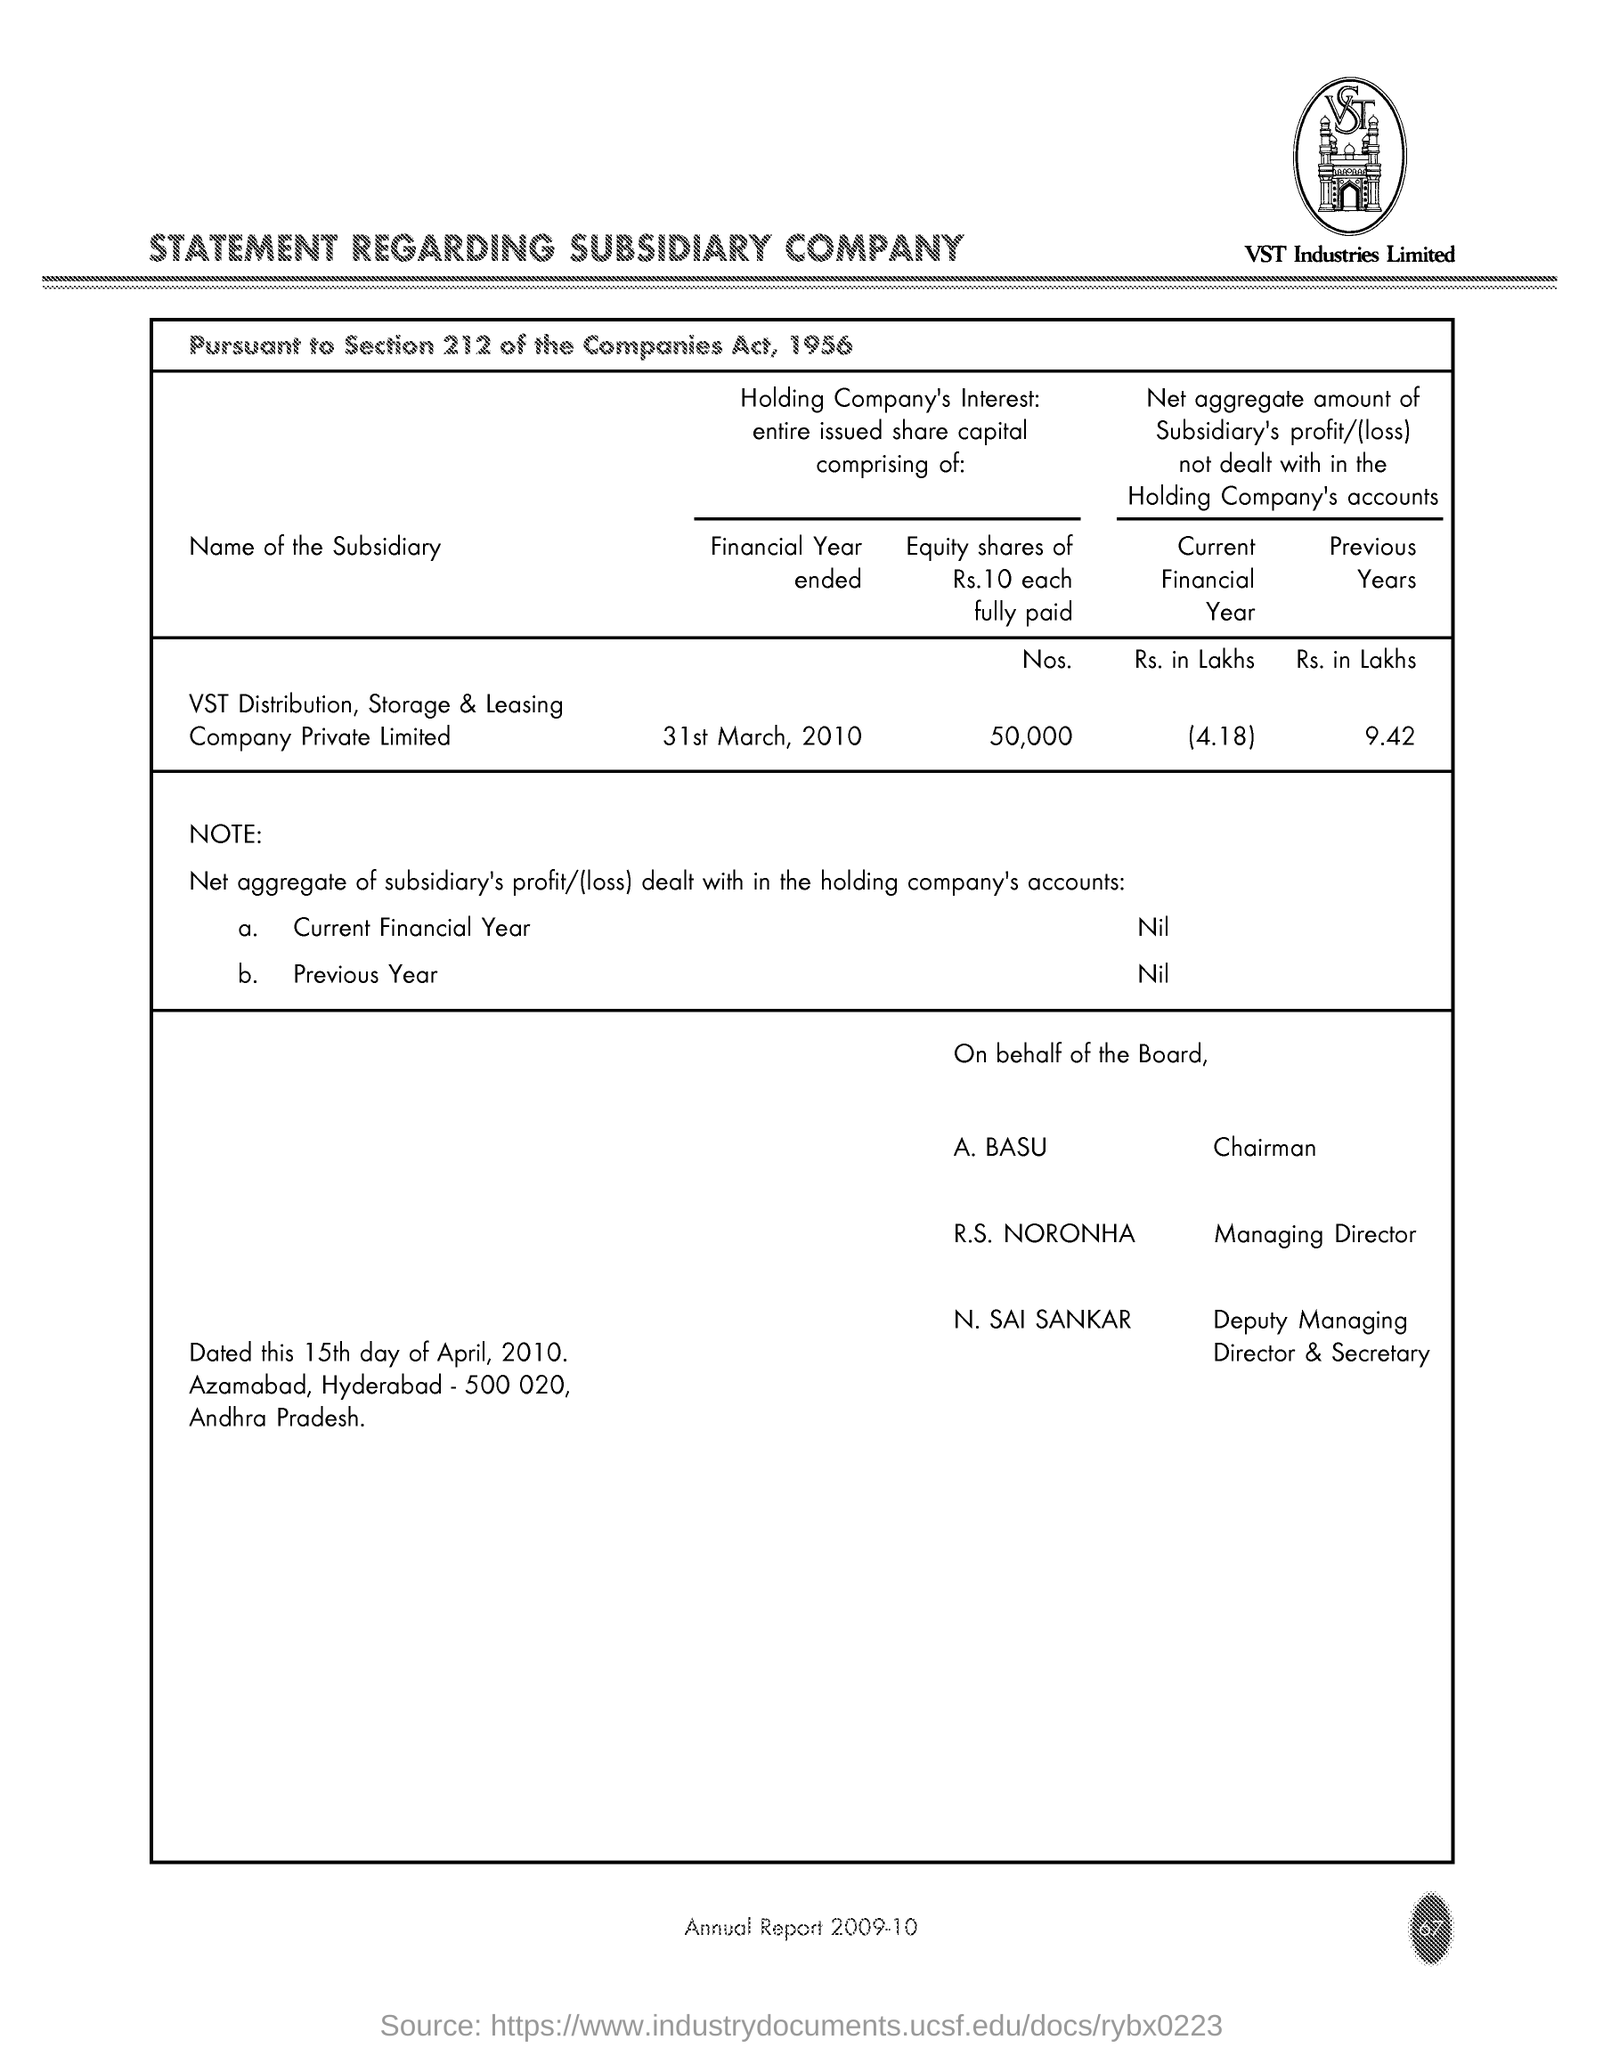Mention a couple of crucial points in this snapshot. The subsidiary did not have any profit or loss in the current financial year that was dealt with by the holding company's accounts. There are 50,000 fully paid equity shares of Rs. 10 each. R.S. NORONHA is the Managing Director. The subsidiary's profit/(loss) in previous years, excluding any amounts dealt within the holding company's accounts, totaled Rs. 9.42 crores. The subsidiary's profit/loss for the current financial year, which has not been dealt with in the holding company's accounts, is Rs. [insert amount] in lakhs. 